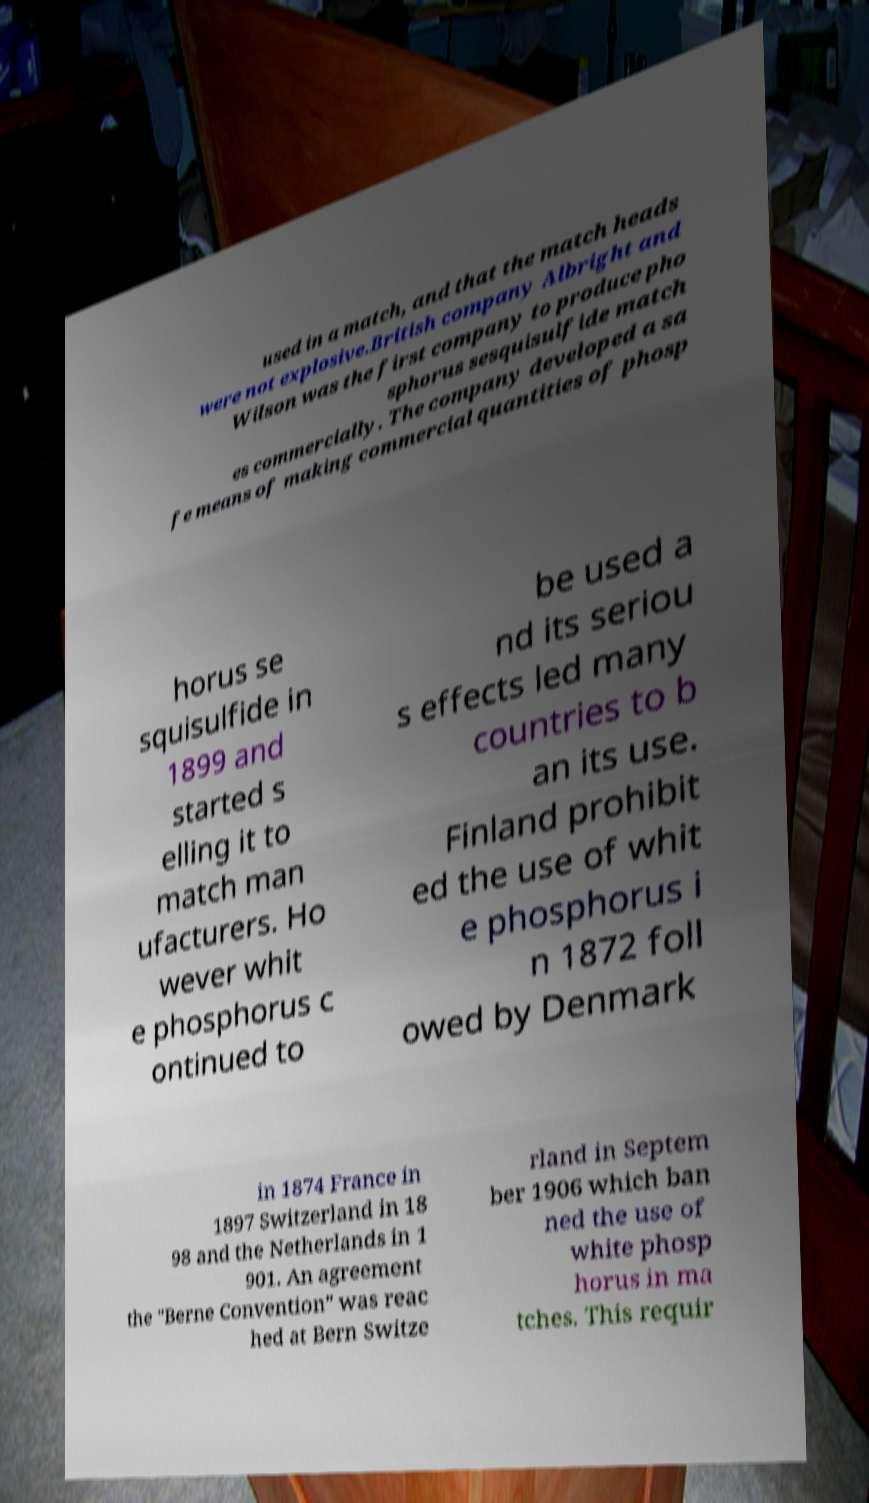Can you read and provide the text displayed in the image?This photo seems to have some interesting text. Can you extract and type it out for me? used in a match, and that the match heads were not explosive.British company Albright and Wilson was the first company to produce pho sphorus sesquisulfide match es commercially. The company developed a sa fe means of making commercial quantities of phosp horus se squisulfide in 1899 and started s elling it to match man ufacturers. Ho wever whit e phosphorus c ontinued to be used a nd its seriou s effects led many countries to b an its use. Finland prohibit ed the use of whit e phosphorus i n 1872 foll owed by Denmark in 1874 France in 1897 Switzerland in 18 98 and the Netherlands in 1 901. An agreement the "Berne Convention" was reac hed at Bern Switze rland in Septem ber 1906 which ban ned the use of white phosp horus in ma tches. This requir 